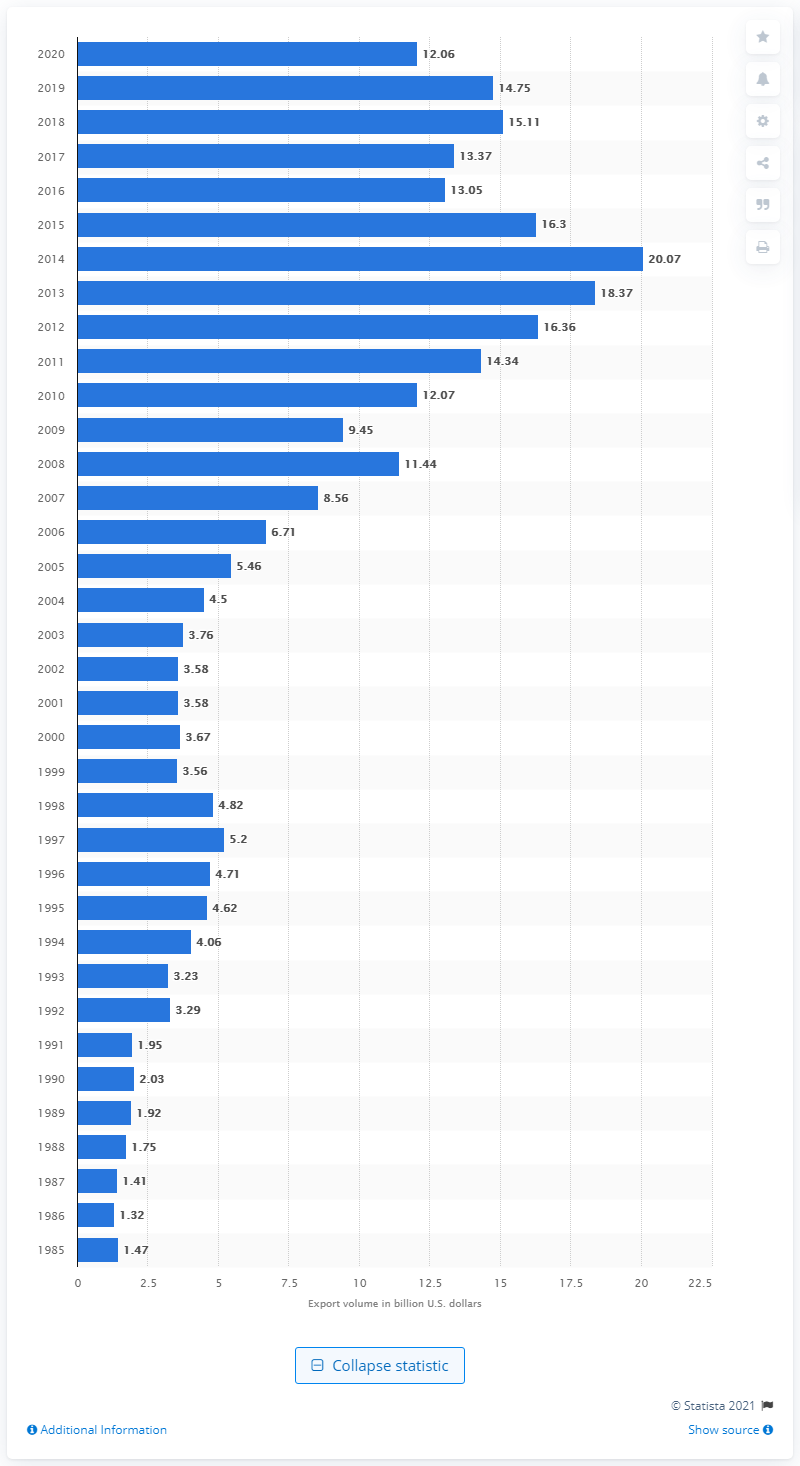Can you describe the trend in U.S. exports to Colombia over the past decade? The image shows a bar chart indicating a general upward trend in U.S. exports to Colombia over the past decade, starting from around 9 billion U.S. dollars in 2010 to hitting a peak at over 16 billion in 2013, followed by slight fluctuations and concluding with around 12 billion in 2020. 